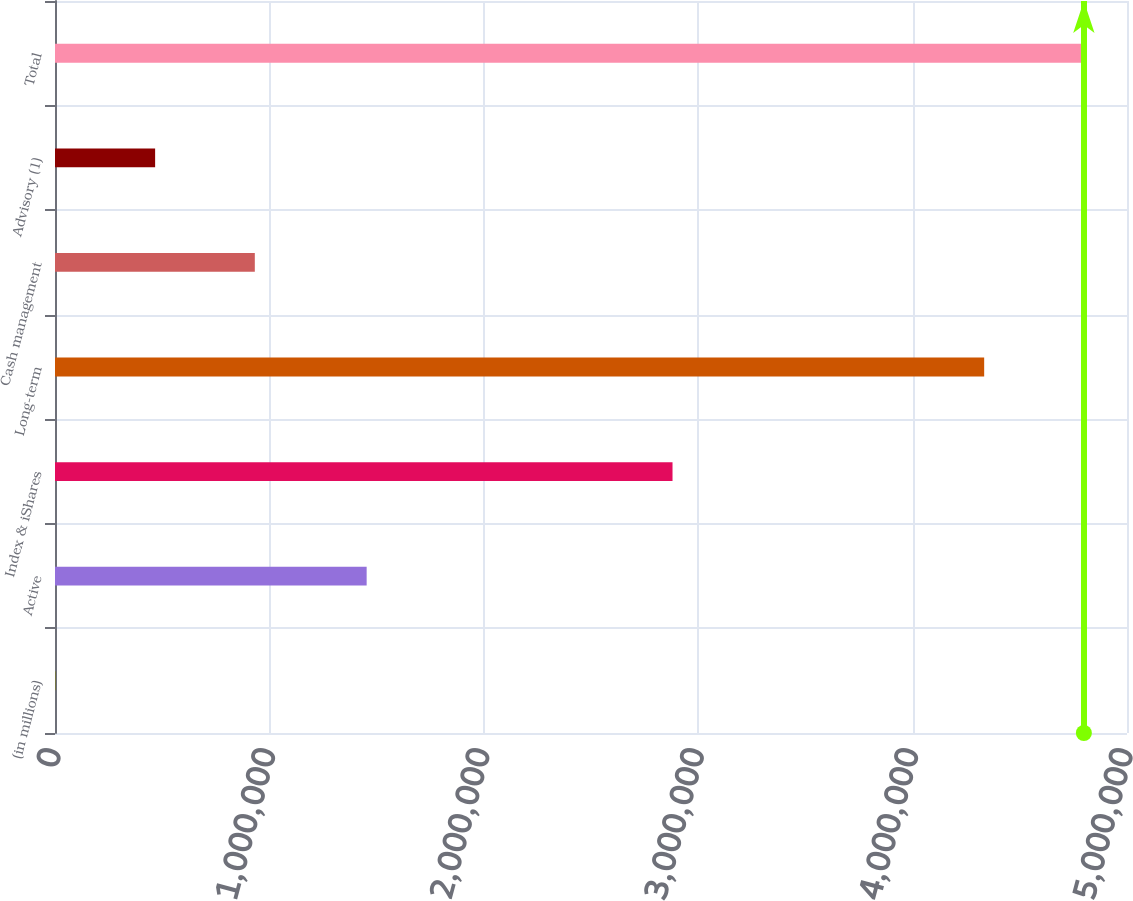Convert chart to OTSL. <chart><loc_0><loc_0><loc_500><loc_500><bar_chart><fcel>(in millions)<fcel>Active<fcel>Index & iShares<fcel>Long-term<fcel>Cash management<fcel>Advisory (1)<fcel>Total<nl><fcel>2014<fcel>1.45361e+06<fcel>2.88023e+06<fcel>4.33384e+06<fcel>931990<fcel>467002<fcel>4.79883e+06<nl></chart> 